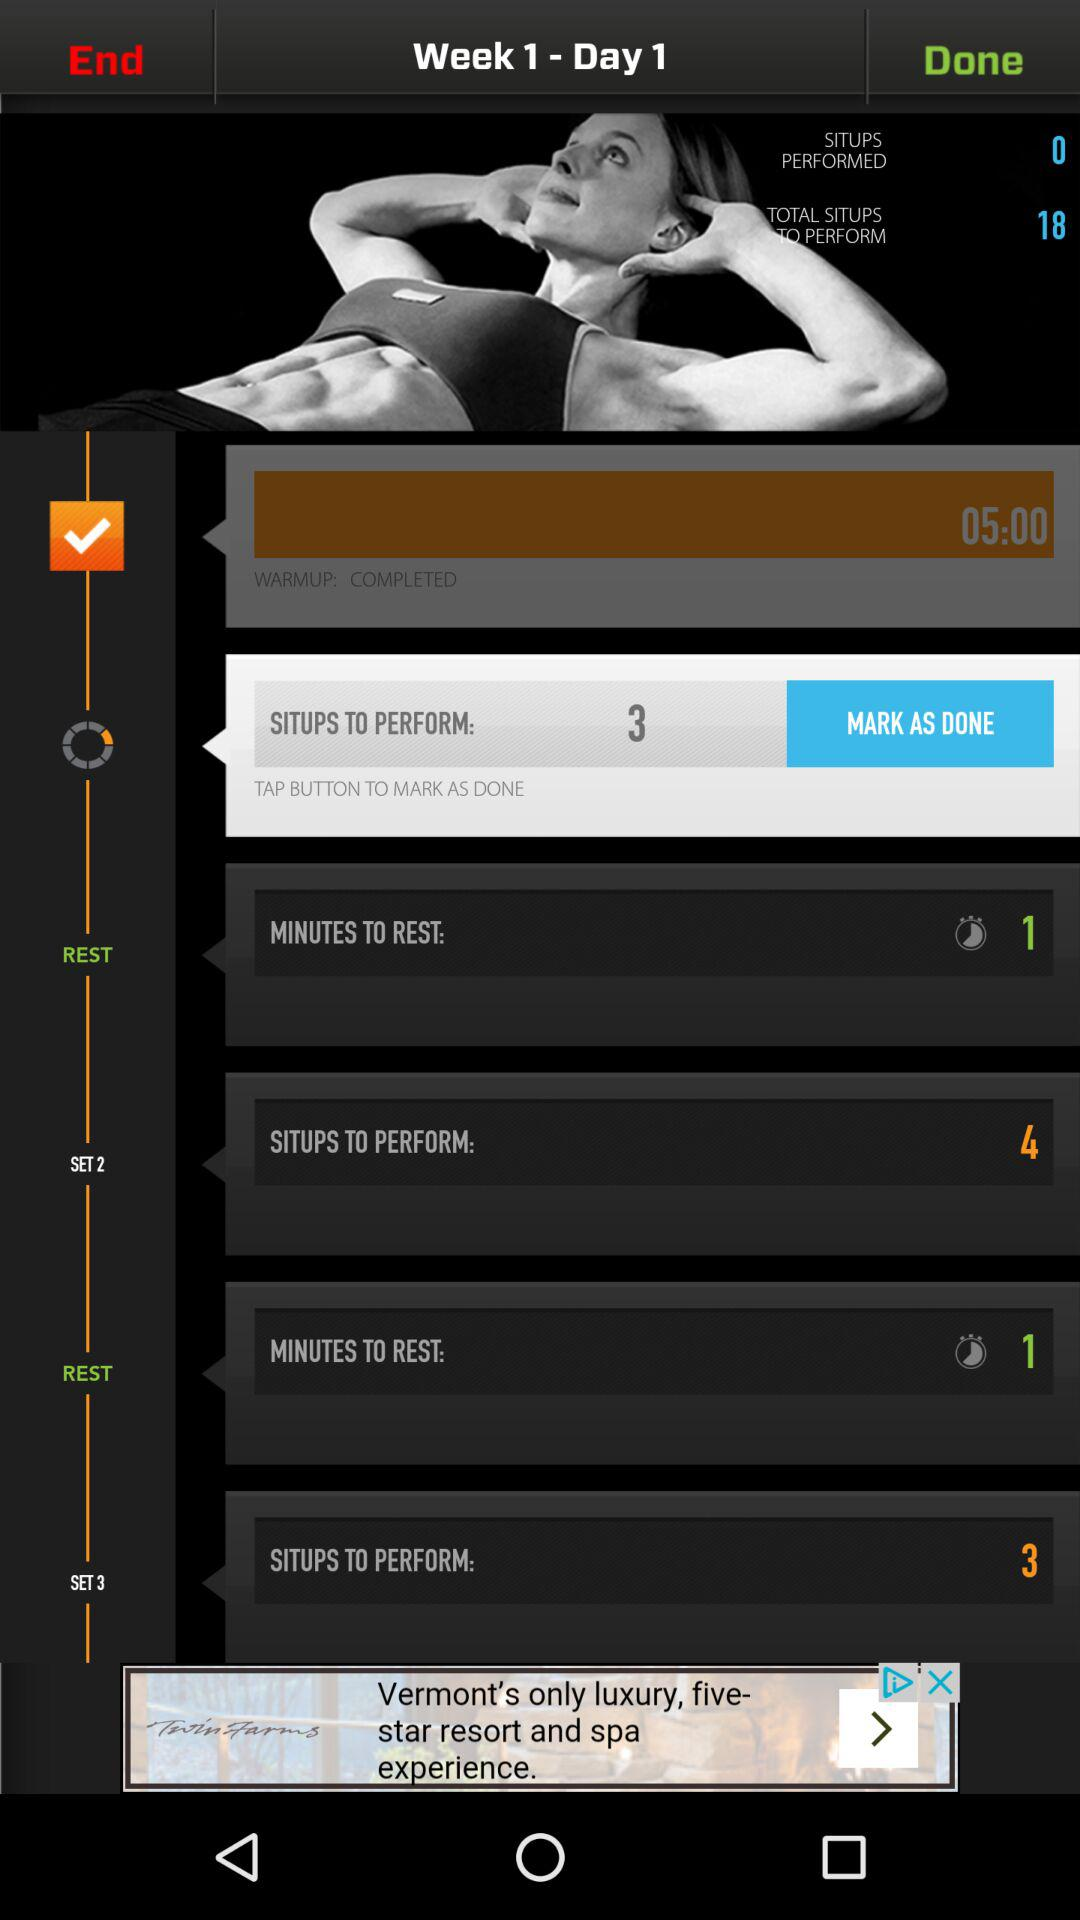How many minutes do I have to rest?
Answer the question using a single word or phrase. 1 